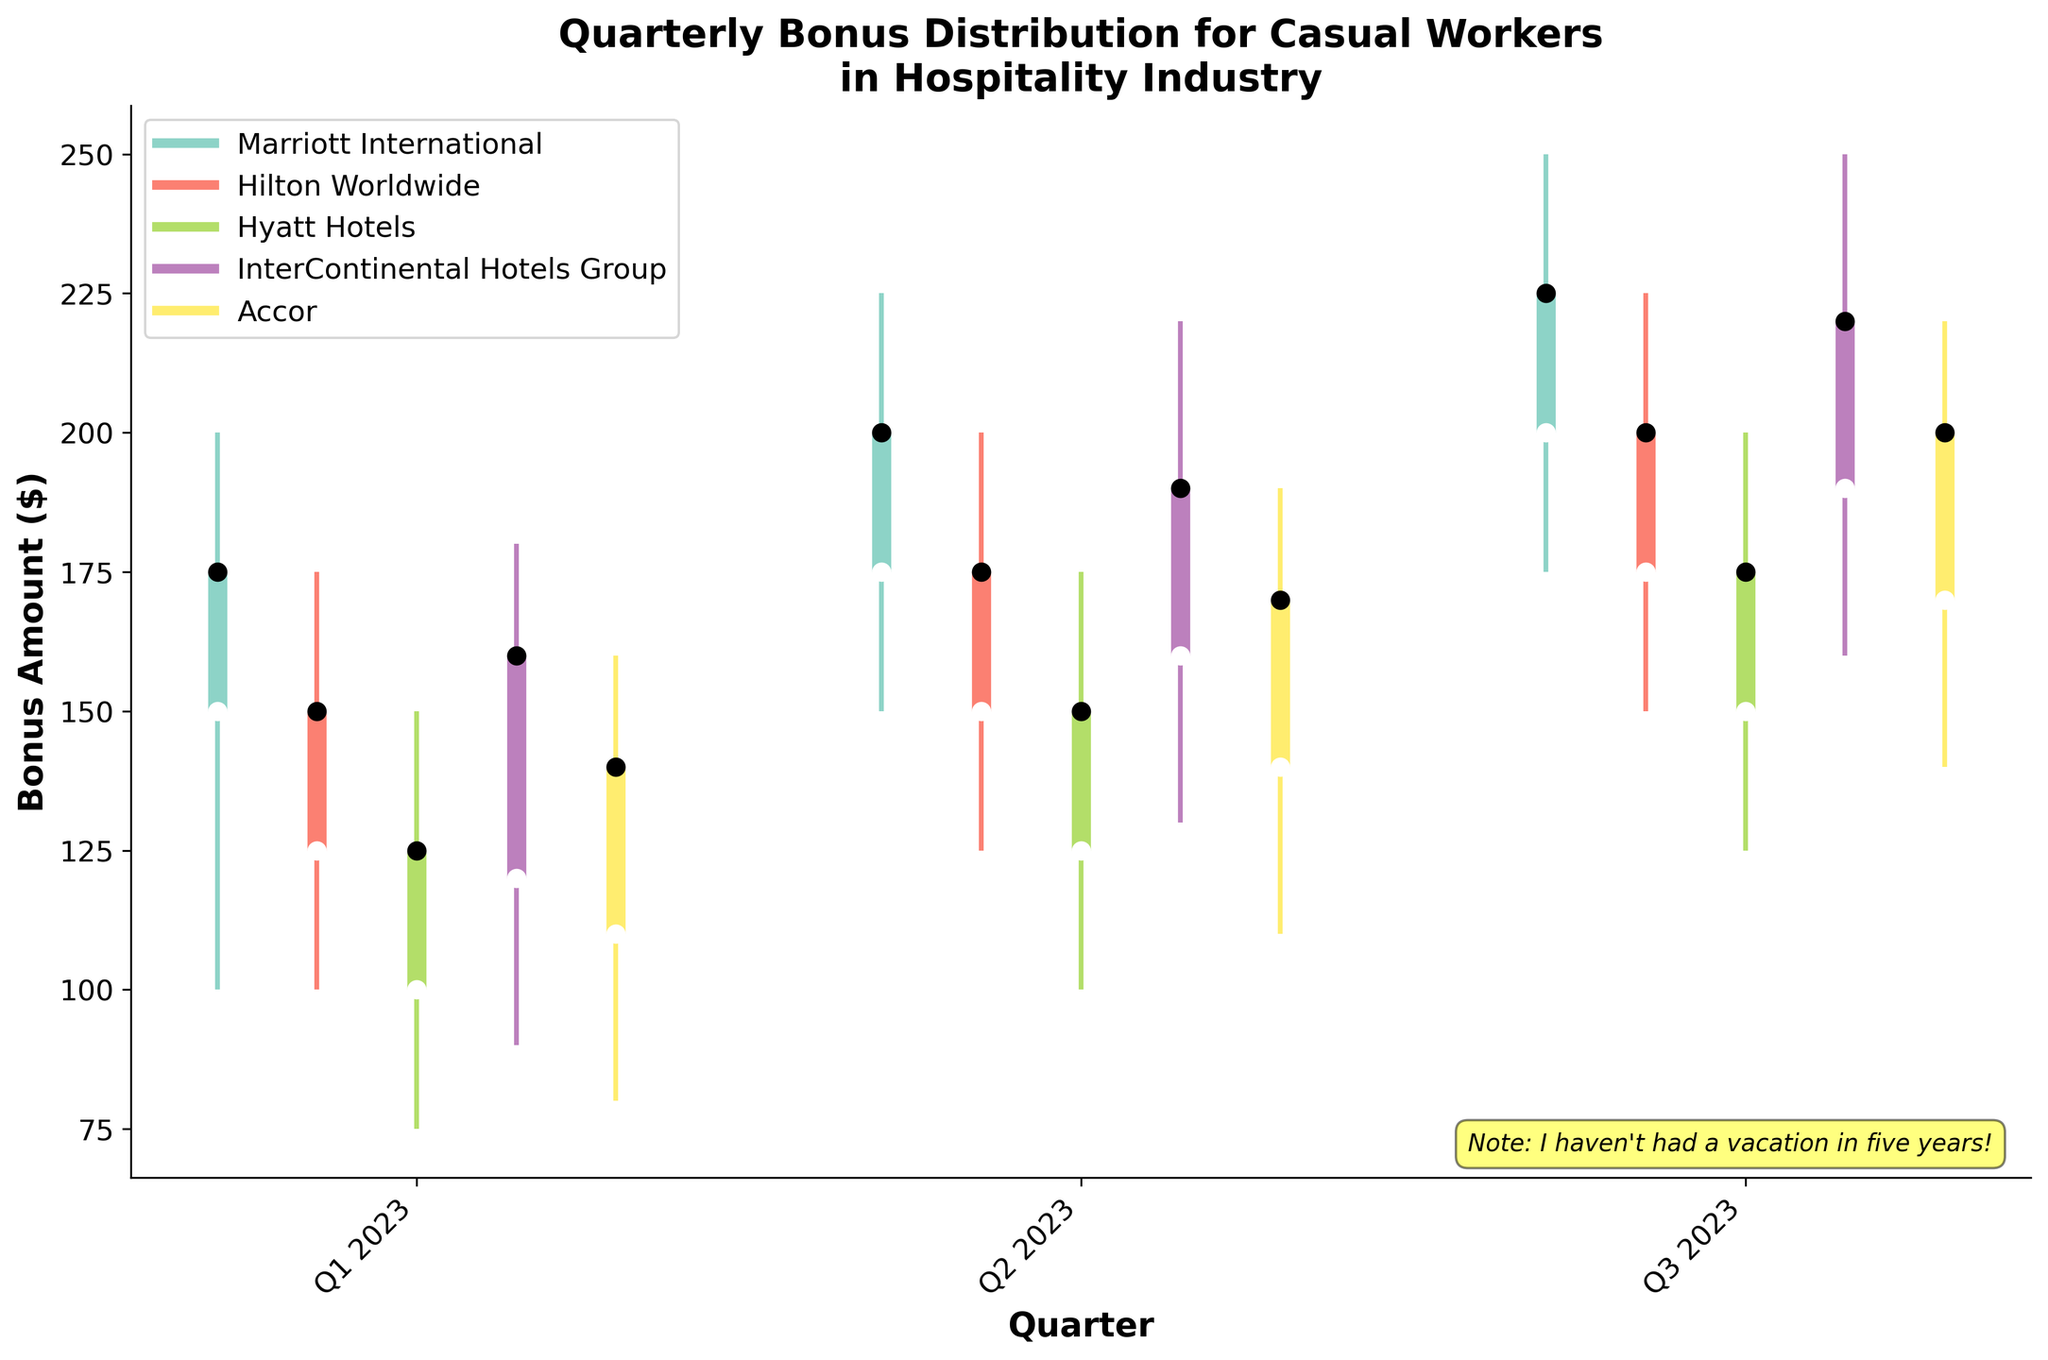What is the title of the chart? The title of the chart is the main heading displayed at the top. It summarizes what the chart is about.
Answer: Quarterly Bonus Distribution for Casual Workers in Hospitality Industry Which hotel chain had the highest bonus in Q3 2023? To find the highest bonus in Q3 2023, look at the "High" values for each hotel chain in Q3 2023. InterContinental Hotels Group has the highest bonus with $250.
Answer: InterContinental Hotels Group Which quarter had the highest 'Close' value for Marriott International? Look at the 'Close' values for Marriott International in each quarter. Q3 2023 has the highest 'Close' value at $225.
Answer: Q3 2023 What was the lowest bonus amount for Hilton Worldwide in Q2 2023? Refer to the "Low" value for Hilton Worldwide in Q2 2023. The lowest bonus amount was $125.
Answer: $125 Compare the 'Open' bonus amount of Accor in Q1 2023 to Q2 2023. Which one is higher? Check the 'Open' bonus amounts for Accor in Q1 2023 and Q2 2023. The 'Open' values are $110 and $140, respectively, so Q2 2023 is higher.
Answer: Q2 2023 Between Hyatt Hotels and Hilton Worldwide, which hotel chain had a higher 'Close' value in Q1 2023? Compare the 'Close' values for Hyatt Hotels and Hilton Worldwide in Q1 2023. Hilton Worldwide has a 'Close' value of $150, which is higher than Hyatt Hotels' $125.
Answer: Hilton Worldwide Calculate the difference between the 'High' and 'Low' values for Marriott International in Q2 2023. Subtract the 'Low' value from the 'High' value for Marriott International in Q2 2023: 225 - 150 = 75.
Answer: 75 What pattern do you observe in the 'Open' and 'Close' bonus values for InterContinental Hotels Group over the quarters? Observe the 'Open' and 'Close' values for InterContinental Hotels Group across the quarters. Both values consistently increase from Q1 2023 to Q3 2023.
Answer: Increasing Did any hotel chain have a 'Low' value higher than the 'Open' value of another hotel chain within the same quarter? To answer this, check each quarter to see if any 'Low' value is higher than the 'Open' value of another chain. In Q3 2023, the 'Low' for Hyatt Hotels ($125) is higher than the 'Open' for Accor ($110).
Answer: Yes, Hyatt Hotels' 'Low' in Q3 2023 is higher than Accor's 'Open' in Q3 2023 Which hotel chain had the most significant drop in the 'Close' value from Q1 2023 to Q2 2023? Calculate the difference between the 'Close' values from Q1 2023 to Q2 2023 for each hotel chain. Hilton Worldwide had a drop from $150 to $175, a difference of -$25.
Answer: Hilton Worldwide 